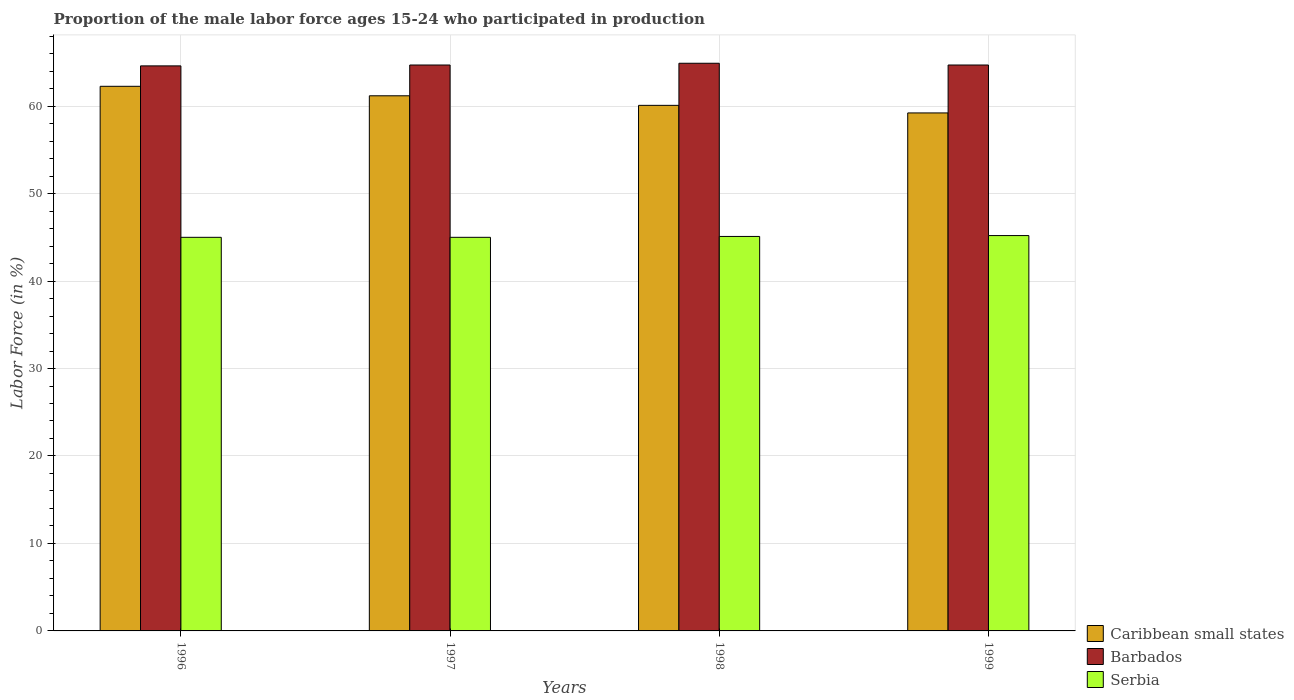How many different coloured bars are there?
Provide a short and direct response. 3. Are the number of bars per tick equal to the number of legend labels?
Make the answer very short. Yes. Are the number of bars on each tick of the X-axis equal?
Ensure brevity in your answer.  Yes. How many bars are there on the 1st tick from the left?
Your response must be concise. 3. How many bars are there on the 3rd tick from the right?
Provide a succinct answer. 3. What is the label of the 3rd group of bars from the left?
Make the answer very short. 1998. In how many cases, is the number of bars for a given year not equal to the number of legend labels?
Keep it short and to the point. 0. Across all years, what is the maximum proportion of the male labor force who participated in production in Barbados?
Make the answer very short. 64.9. Across all years, what is the minimum proportion of the male labor force who participated in production in Caribbean small states?
Offer a very short reply. 59.22. In which year was the proportion of the male labor force who participated in production in Caribbean small states maximum?
Offer a very short reply. 1996. In which year was the proportion of the male labor force who participated in production in Barbados minimum?
Provide a short and direct response. 1996. What is the total proportion of the male labor force who participated in production in Serbia in the graph?
Give a very brief answer. 180.3. What is the difference between the proportion of the male labor force who participated in production in Barbados in 1996 and that in 1999?
Keep it short and to the point. -0.1. What is the difference between the proportion of the male labor force who participated in production in Barbados in 1997 and the proportion of the male labor force who participated in production in Caribbean small states in 1996?
Offer a terse response. 2.43. What is the average proportion of the male labor force who participated in production in Barbados per year?
Your response must be concise. 64.72. In the year 1998, what is the difference between the proportion of the male labor force who participated in production in Serbia and proportion of the male labor force who participated in production in Barbados?
Keep it short and to the point. -19.8. What is the ratio of the proportion of the male labor force who participated in production in Barbados in 1998 to that in 1999?
Keep it short and to the point. 1. What is the difference between the highest and the second highest proportion of the male labor force who participated in production in Caribbean small states?
Give a very brief answer. 1.08. What is the difference between the highest and the lowest proportion of the male labor force who participated in production in Serbia?
Your response must be concise. 0.2. Is the sum of the proportion of the male labor force who participated in production in Barbados in 1996 and 1998 greater than the maximum proportion of the male labor force who participated in production in Serbia across all years?
Keep it short and to the point. Yes. What does the 3rd bar from the left in 1996 represents?
Provide a short and direct response. Serbia. What does the 2nd bar from the right in 1998 represents?
Keep it short and to the point. Barbados. Is it the case that in every year, the sum of the proportion of the male labor force who participated in production in Barbados and proportion of the male labor force who participated in production in Serbia is greater than the proportion of the male labor force who participated in production in Caribbean small states?
Offer a terse response. Yes. Are all the bars in the graph horizontal?
Keep it short and to the point. No. How many years are there in the graph?
Provide a short and direct response. 4. Are the values on the major ticks of Y-axis written in scientific E-notation?
Offer a very short reply. No. Does the graph contain any zero values?
Make the answer very short. No. What is the title of the graph?
Make the answer very short. Proportion of the male labor force ages 15-24 who participated in production. Does "Armenia" appear as one of the legend labels in the graph?
Make the answer very short. No. What is the label or title of the Y-axis?
Give a very brief answer. Labor Force (in %). What is the Labor Force (in %) of Caribbean small states in 1996?
Your answer should be very brief. 62.27. What is the Labor Force (in %) in Barbados in 1996?
Keep it short and to the point. 64.6. What is the Labor Force (in %) of Serbia in 1996?
Your answer should be compact. 45. What is the Labor Force (in %) in Caribbean small states in 1997?
Give a very brief answer. 61.18. What is the Labor Force (in %) in Barbados in 1997?
Offer a very short reply. 64.7. What is the Labor Force (in %) of Serbia in 1997?
Give a very brief answer. 45. What is the Labor Force (in %) of Caribbean small states in 1998?
Keep it short and to the point. 60.09. What is the Labor Force (in %) in Barbados in 1998?
Provide a short and direct response. 64.9. What is the Labor Force (in %) in Serbia in 1998?
Your response must be concise. 45.1. What is the Labor Force (in %) in Caribbean small states in 1999?
Make the answer very short. 59.22. What is the Labor Force (in %) of Barbados in 1999?
Offer a very short reply. 64.7. What is the Labor Force (in %) of Serbia in 1999?
Offer a terse response. 45.2. Across all years, what is the maximum Labor Force (in %) in Caribbean small states?
Your answer should be compact. 62.27. Across all years, what is the maximum Labor Force (in %) in Barbados?
Your response must be concise. 64.9. Across all years, what is the maximum Labor Force (in %) of Serbia?
Your response must be concise. 45.2. Across all years, what is the minimum Labor Force (in %) of Caribbean small states?
Your response must be concise. 59.22. Across all years, what is the minimum Labor Force (in %) in Barbados?
Give a very brief answer. 64.6. What is the total Labor Force (in %) in Caribbean small states in the graph?
Give a very brief answer. 242.76. What is the total Labor Force (in %) of Barbados in the graph?
Offer a very short reply. 258.9. What is the total Labor Force (in %) of Serbia in the graph?
Your answer should be very brief. 180.3. What is the difference between the Labor Force (in %) in Caribbean small states in 1996 and that in 1997?
Give a very brief answer. 1.08. What is the difference between the Labor Force (in %) of Caribbean small states in 1996 and that in 1998?
Provide a short and direct response. 2.18. What is the difference between the Labor Force (in %) in Barbados in 1996 and that in 1998?
Give a very brief answer. -0.3. What is the difference between the Labor Force (in %) in Caribbean small states in 1996 and that in 1999?
Your response must be concise. 3.04. What is the difference between the Labor Force (in %) in Caribbean small states in 1997 and that in 1998?
Provide a succinct answer. 1.09. What is the difference between the Labor Force (in %) of Barbados in 1997 and that in 1998?
Provide a succinct answer. -0.2. What is the difference between the Labor Force (in %) of Caribbean small states in 1997 and that in 1999?
Provide a short and direct response. 1.96. What is the difference between the Labor Force (in %) in Barbados in 1997 and that in 1999?
Offer a terse response. 0. What is the difference between the Labor Force (in %) in Caribbean small states in 1998 and that in 1999?
Make the answer very short. 0.87. What is the difference between the Labor Force (in %) of Barbados in 1998 and that in 1999?
Keep it short and to the point. 0.2. What is the difference between the Labor Force (in %) of Serbia in 1998 and that in 1999?
Your response must be concise. -0.1. What is the difference between the Labor Force (in %) of Caribbean small states in 1996 and the Labor Force (in %) of Barbados in 1997?
Keep it short and to the point. -2.43. What is the difference between the Labor Force (in %) of Caribbean small states in 1996 and the Labor Force (in %) of Serbia in 1997?
Your answer should be compact. 17.27. What is the difference between the Labor Force (in %) of Barbados in 1996 and the Labor Force (in %) of Serbia in 1997?
Your answer should be compact. 19.6. What is the difference between the Labor Force (in %) of Caribbean small states in 1996 and the Labor Force (in %) of Barbados in 1998?
Make the answer very short. -2.63. What is the difference between the Labor Force (in %) in Caribbean small states in 1996 and the Labor Force (in %) in Serbia in 1998?
Provide a short and direct response. 17.17. What is the difference between the Labor Force (in %) in Barbados in 1996 and the Labor Force (in %) in Serbia in 1998?
Your response must be concise. 19.5. What is the difference between the Labor Force (in %) in Caribbean small states in 1996 and the Labor Force (in %) in Barbados in 1999?
Your answer should be compact. -2.43. What is the difference between the Labor Force (in %) of Caribbean small states in 1996 and the Labor Force (in %) of Serbia in 1999?
Offer a terse response. 17.07. What is the difference between the Labor Force (in %) in Caribbean small states in 1997 and the Labor Force (in %) in Barbados in 1998?
Keep it short and to the point. -3.72. What is the difference between the Labor Force (in %) in Caribbean small states in 1997 and the Labor Force (in %) in Serbia in 1998?
Your answer should be very brief. 16.08. What is the difference between the Labor Force (in %) of Barbados in 1997 and the Labor Force (in %) of Serbia in 1998?
Ensure brevity in your answer.  19.6. What is the difference between the Labor Force (in %) in Caribbean small states in 1997 and the Labor Force (in %) in Barbados in 1999?
Provide a short and direct response. -3.52. What is the difference between the Labor Force (in %) of Caribbean small states in 1997 and the Labor Force (in %) of Serbia in 1999?
Your answer should be very brief. 15.98. What is the difference between the Labor Force (in %) in Caribbean small states in 1998 and the Labor Force (in %) in Barbados in 1999?
Your response must be concise. -4.61. What is the difference between the Labor Force (in %) of Caribbean small states in 1998 and the Labor Force (in %) of Serbia in 1999?
Ensure brevity in your answer.  14.89. What is the difference between the Labor Force (in %) of Barbados in 1998 and the Labor Force (in %) of Serbia in 1999?
Ensure brevity in your answer.  19.7. What is the average Labor Force (in %) of Caribbean small states per year?
Your answer should be very brief. 60.69. What is the average Labor Force (in %) in Barbados per year?
Your answer should be compact. 64.72. What is the average Labor Force (in %) of Serbia per year?
Provide a short and direct response. 45.08. In the year 1996, what is the difference between the Labor Force (in %) in Caribbean small states and Labor Force (in %) in Barbados?
Provide a short and direct response. -2.33. In the year 1996, what is the difference between the Labor Force (in %) in Caribbean small states and Labor Force (in %) in Serbia?
Keep it short and to the point. 17.27. In the year 1996, what is the difference between the Labor Force (in %) of Barbados and Labor Force (in %) of Serbia?
Offer a very short reply. 19.6. In the year 1997, what is the difference between the Labor Force (in %) of Caribbean small states and Labor Force (in %) of Barbados?
Provide a short and direct response. -3.52. In the year 1997, what is the difference between the Labor Force (in %) in Caribbean small states and Labor Force (in %) in Serbia?
Offer a terse response. 16.18. In the year 1997, what is the difference between the Labor Force (in %) in Barbados and Labor Force (in %) in Serbia?
Offer a very short reply. 19.7. In the year 1998, what is the difference between the Labor Force (in %) in Caribbean small states and Labor Force (in %) in Barbados?
Your response must be concise. -4.81. In the year 1998, what is the difference between the Labor Force (in %) in Caribbean small states and Labor Force (in %) in Serbia?
Provide a short and direct response. 14.99. In the year 1998, what is the difference between the Labor Force (in %) in Barbados and Labor Force (in %) in Serbia?
Ensure brevity in your answer.  19.8. In the year 1999, what is the difference between the Labor Force (in %) in Caribbean small states and Labor Force (in %) in Barbados?
Provide a succinct answer. -5.48. In the year 1999, what is the difference between the Labor Force (in %) of Caribbean small states and Labor Force (in %) of Serbia?
Your answer should be very brief. 14.02. In the year 1999, what is the difference between the Labor Force (in %) in Barbados and Labor Force (in %) in Serbia?
Ensure brevity in your answer.  19.5. What is the ratio of the Labor Force (in %) of Caribbean small states in 1996 to that in 1997?
Ensure brevity in your answer.  1.02. What is the ratio of the Labor Force (in %) in Caribbean small states in 1996 to that in 1998?
Offer a very short reply. 1.04. What is the ratio of the Labor Force (in %) of Serbia in 1996 to that in 1998?
Provide a short and direct response. 1. What is the ratio of the Labor Force (in %) of Caribbean small states in 1996 to that in 1999?
Ensure brevity in your answer.  1.05. What is the ratio of the Labor Force (in %) of Caribbean small states in 1997 to that in 1998?
Your answer should be compact. 1.02. What is the ratio of the Labor Force (in %) in Barbados in 1997 to that in 1998?
Offer a terse response. 1. What is the ratio of the Labor Force (in %) of Caribbean small states in 1997 to that in 1999?
Your answer should be compact. 1.03. What is the ratio of the Labor Force (in %) in Serbia in 1997 to that in 1999?
Your answer should be compact. 1. What is the ratio of the Labor Force (in %) in Caribbean small states in 1998 to that in 1999?
Provide a succinct answer. 1.01. What is the difference between the highest and the second highest Labor Force (in %) in Caribbean small states?
Ensure brevity in your answer.  1.08. What is the difference between the highest and the second highest Labor Force (in %) in Barbados?
Keep it short and to the point. 0.2. What is the difference between the highest and the second highest Labor Force (in %) in Serbia?
Provide a succinct answer. 0.1. What is the difference between the highest and the lowest Labor Force (in %) in Caribbean small states?
Offer a very short reply. 3.04. What is the difference between the highest and the lowest Labor Force (in %) of Barbados?
Ensure brevity in your answer.  0.3. 